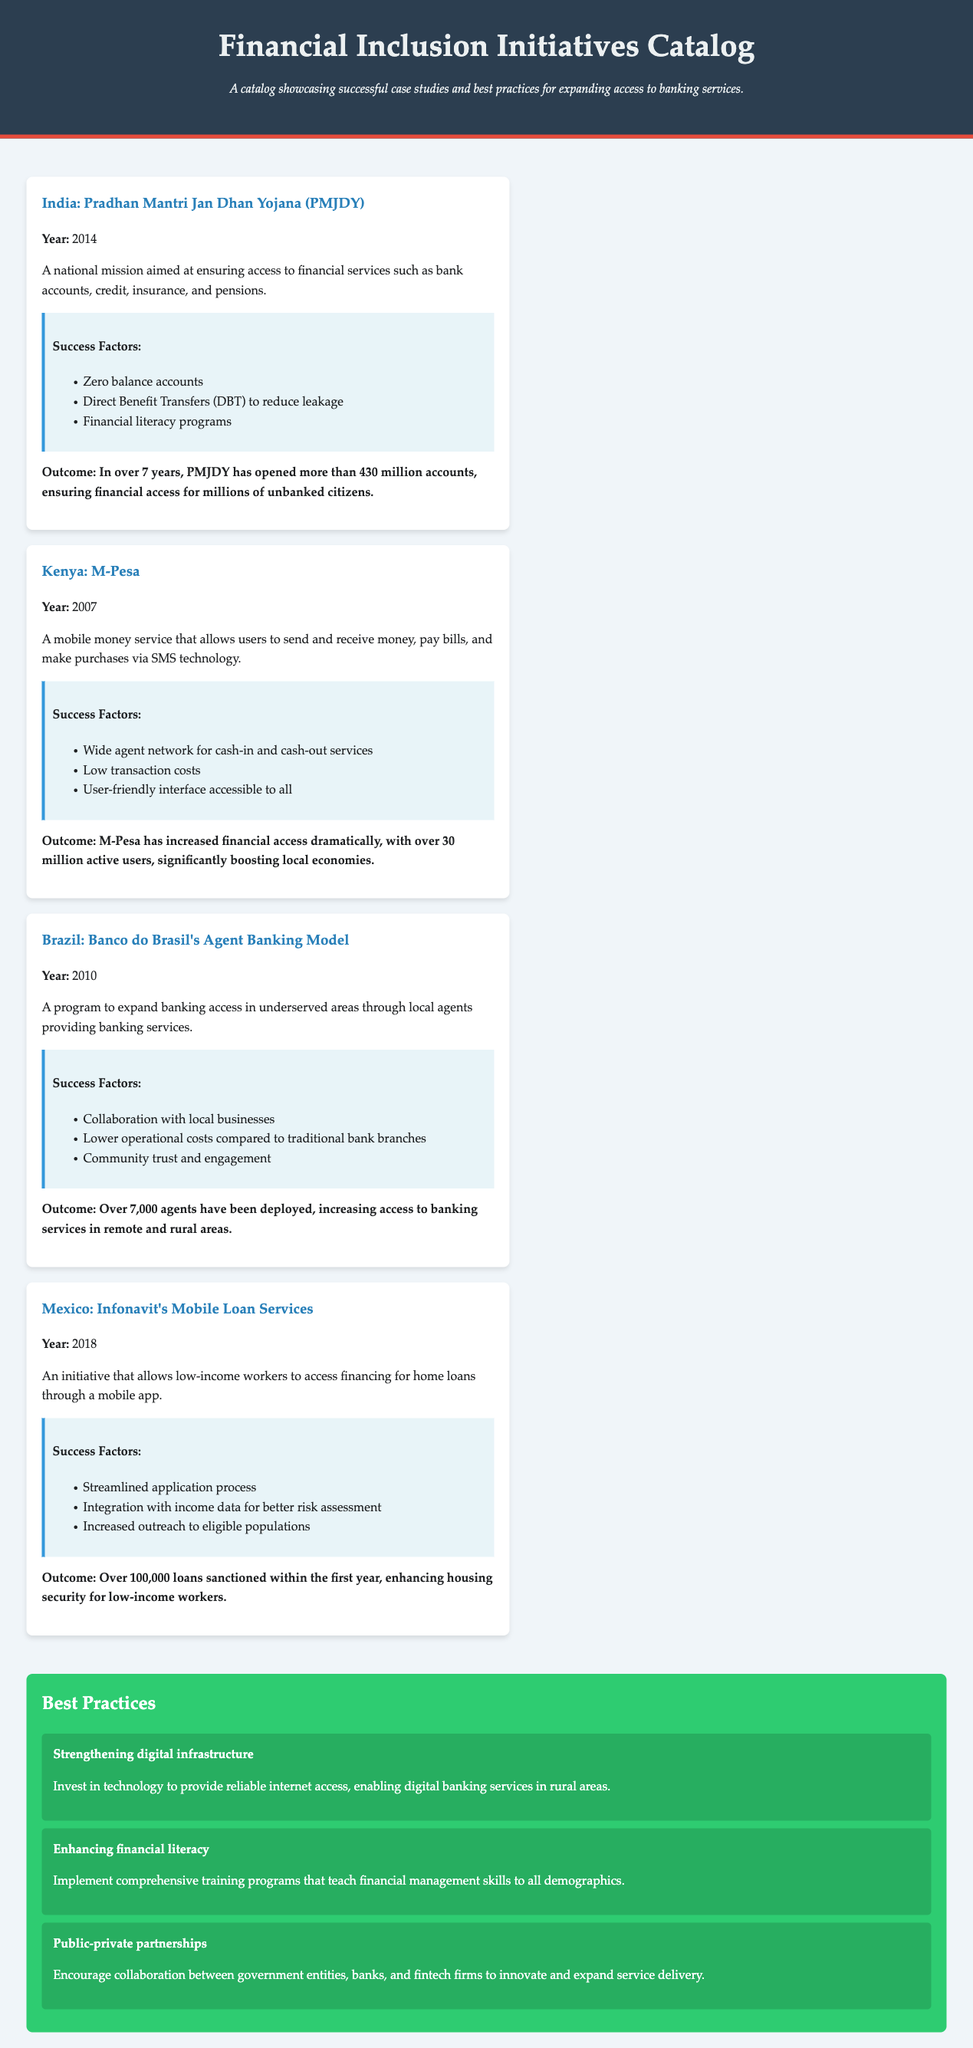What is the year India launched PMJDY? PMJDY was launched in 2014, as mentioned in the case study section.
Answer: 2014 How many accounts were opened through PMJDY over seven years? The document states that PMJDY opened more than 430 million accounts.
Answer: 430 million What mobile money service was introduced in Kenya in 2007? The case study specifically mentions M-Pesa as the service launched in Kenya.
Answer: M-Pesa Which country implemented a mobile loan service through a mobile app in 2018? The document highlights Mexico's initiative in this area.
Answer: Mexico What is a key success factor of Banco do Brasil's Agent Banking Model? The case study lists collaboration with local businesses as a success factor.
Answer: Collaboration with local businesses How many active users did M-Pesa have, according to the document? The document states that M-Pesa has over 30 million active users.
Answer: Over 30 million What is one of the best practices mentioned for financial inclusion? The document lists strengthening digital infrastructure as a best practice.
Answer: Strengthening digital infrastructure What is the outcome of Infonavit's Mobile Loan Services? The document mentions that over 100,000 loans were sanctioned within the first year.
Answer: Over 100,000 loans Which financial inclusion initiative is aimed at ensuring access to credit, insurance, and pensions? The PMJDY case study explicitly states this objective.
Answer: PMJDY What does the outcome of Banco do Brasil's Agent Banking Model mention? The outcome highlights increased access to banking services in remote and rural areas.
Answer: Increased access to banking services in remote and rural areas 